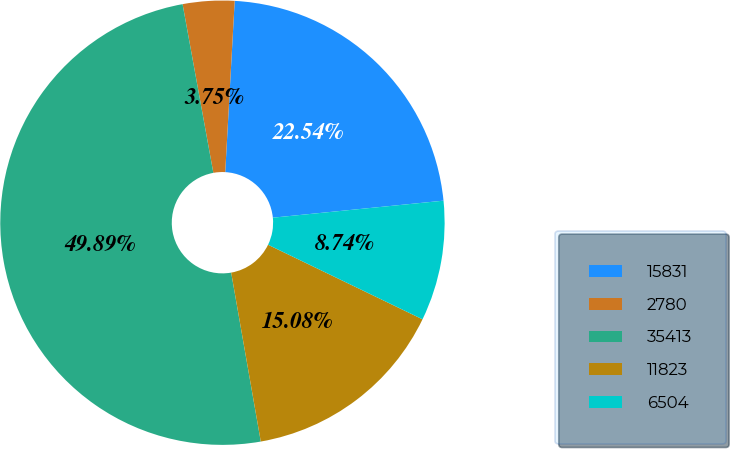<chart> <loc_0><loc_0><loc_500><loc_500><pie_chart><fcel>15831<fcel>2780<fcel>35413<fcel>11823<fcel>6504<nl><fcel>22.54%<fcel>3.75%<fcel>49.89%<fcel>15.08%<fcel>8.74%<nl></chart> 